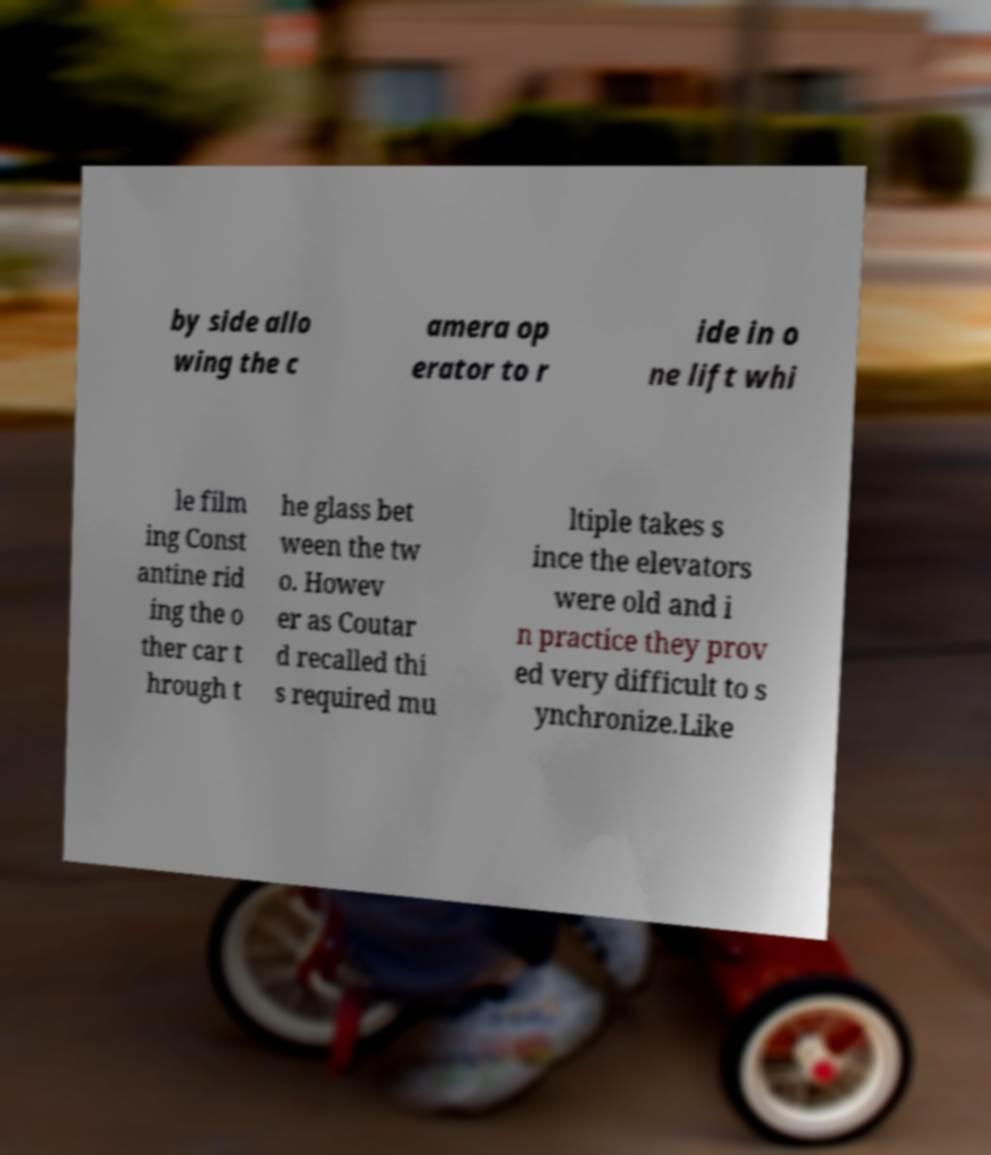I need the written content from this picture converted into text. Can you do that? by side allo wing the c amera op erator to r ide in o ne lift whi le film ing Const antine rid ing the o ther car t hrough t he glass bet ween the tw o. Howev er as Coutar d recalled thi s required mu ltiple takes s ince the elevators were old and i n practice they prov ed very difficult to s ynchronize.Like 